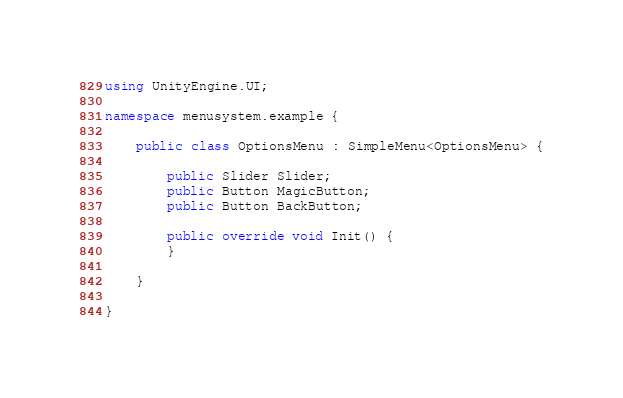<code> <loc_0><loc_0><loc_500><loc_500><_C#_>using UnityEngine.UI;

namespace menusystem.example {

    public class OptionsMenu : SimpleMenu<OptionsMenu> {

        public Slider Slider;
        public Button MagicButton;
        public Button BackButton;

        public override void Init() {
        }

    }

}</code> 